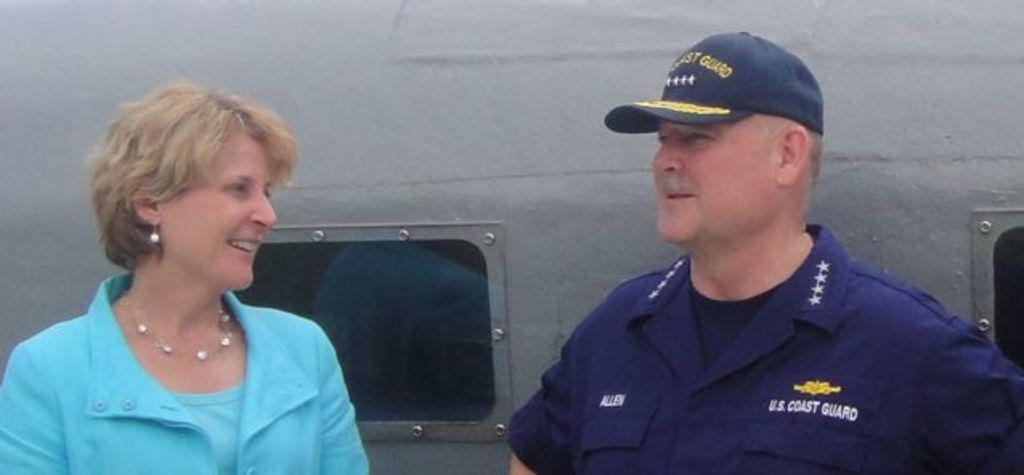<image>
Offer a succinct explanation of the picture presented. A woman is speaking to a man from the U.S. Coast Guard. 